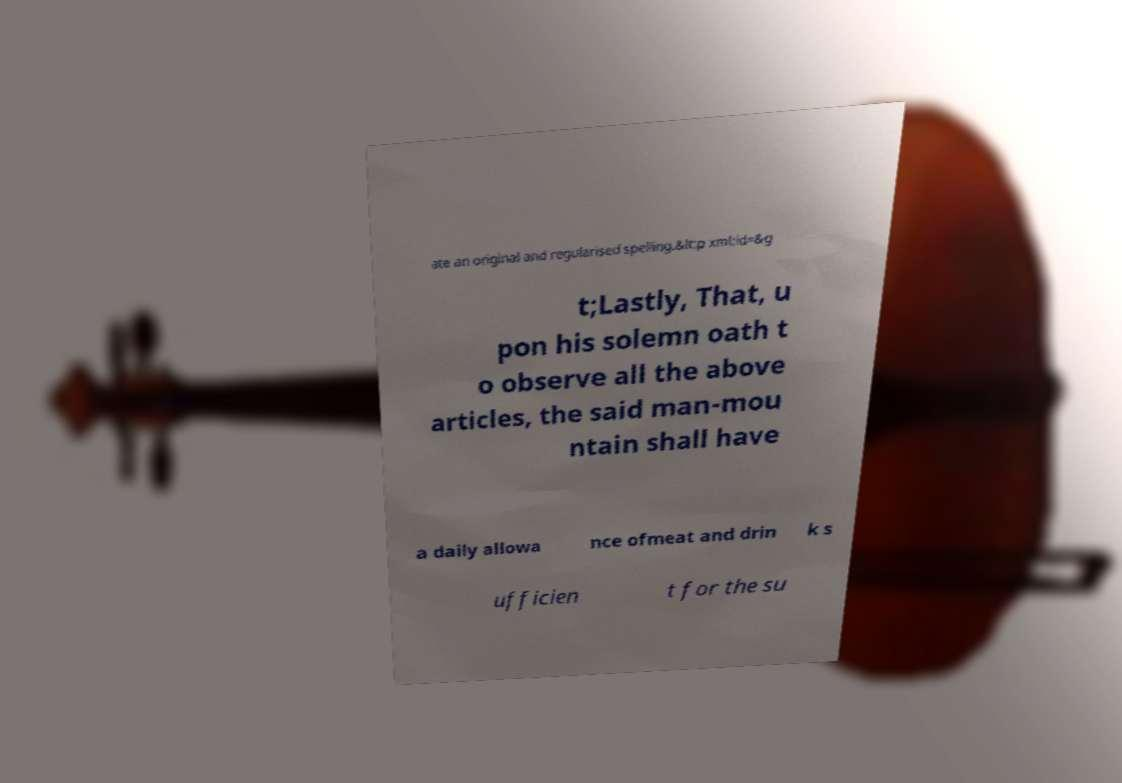Could you assist in decoding the text presented in this image and type it out clearly? ate an original and regularised spelling.&lt;p xml:id=&g t;Lastly, That, u pon his solemn oath t o observe all the above articles, the said man-mou ntain shall have a daily allowa nce ofmeat and drin k s ufficien t for the su 